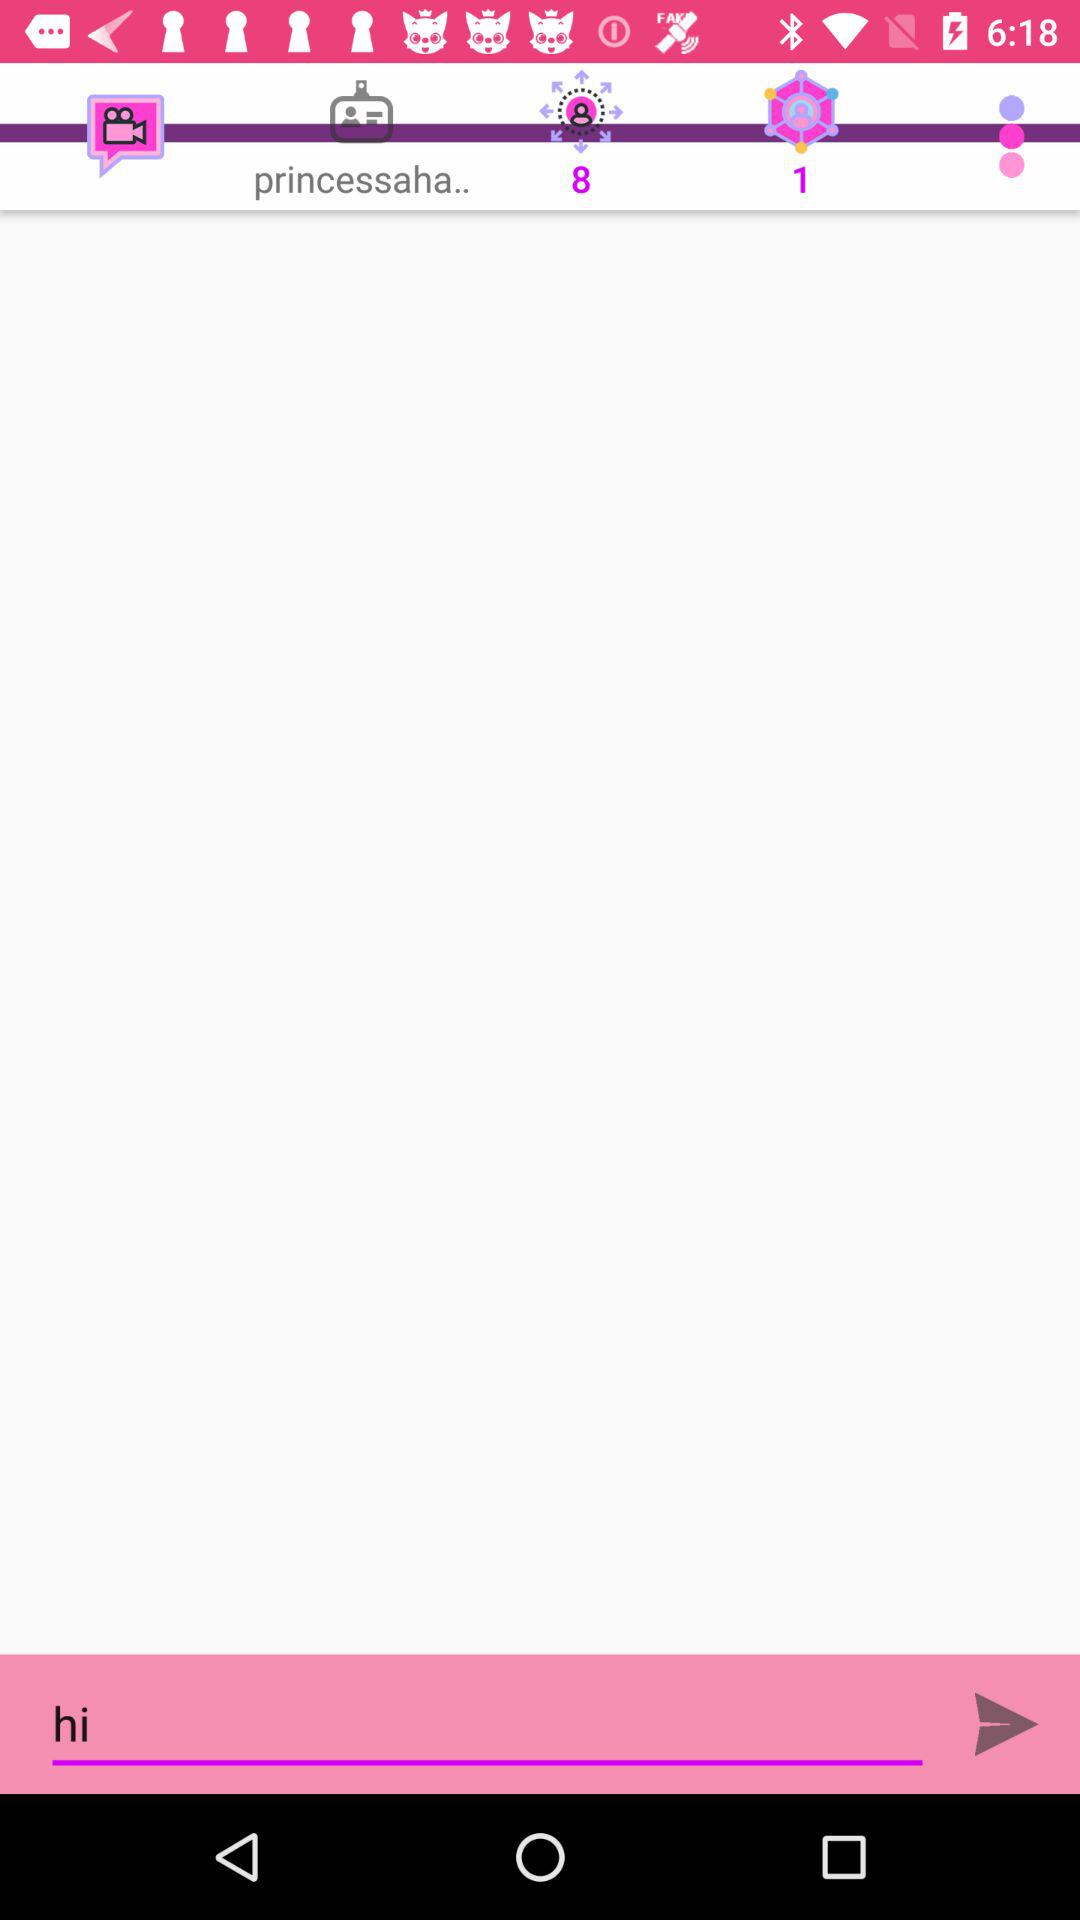How many more people are in the group chat than there are purple circles in the chat?
Answer the question using a single word or phrase. 7 